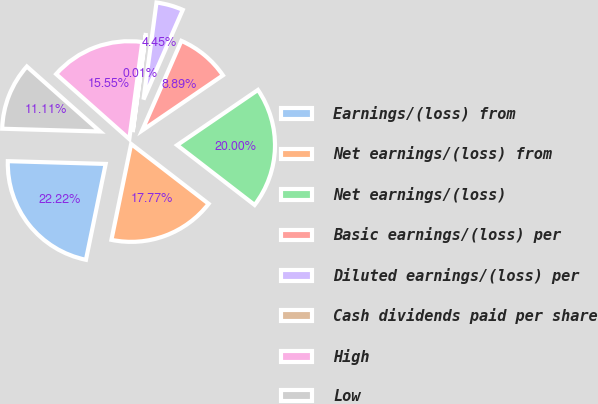<chart> <loc_0><loc_0><loc_500><loc_500><pie_chart><fcel>Earnings/(loss) from<fcel>Net earnings/(loss) from<fcel>Net earnings/(loss)<fcel>Basic earnings/(loss) per<fcel>Diluted earnings/(loss) per<fcel>Cash dividends paid per share<fcel>High<fcel>Low<nl><fcel>22.22%<fcel>17.77%<fcel>20.0%<fcel>8.89%<fcel>4.45%<fcel>0.01%<fcel>15.55%<fcel>11.11%<nl></chart> 